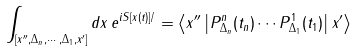Convert formula to latex. <formula><loc_0><loc_0><loc_500><loc_500>\int _ { [ x ^ { \prime \prime } , \Delta _ { n } , \cdots , \Delta _ { 1 } , x ^ { \prime } ] } d x \, e ^ { i S [ x ( t ) ] / } = \left \langle x ^ { \prime \prime } \left | P ^ { n } _ { \Delta _ { n } } ( t _ { n } ) \cdots P ^ { 1 } _ { \Delta _ { 1 } } ( t _ { 1 } ) \right | x ^ { \prime } \right \rangle</formula> 